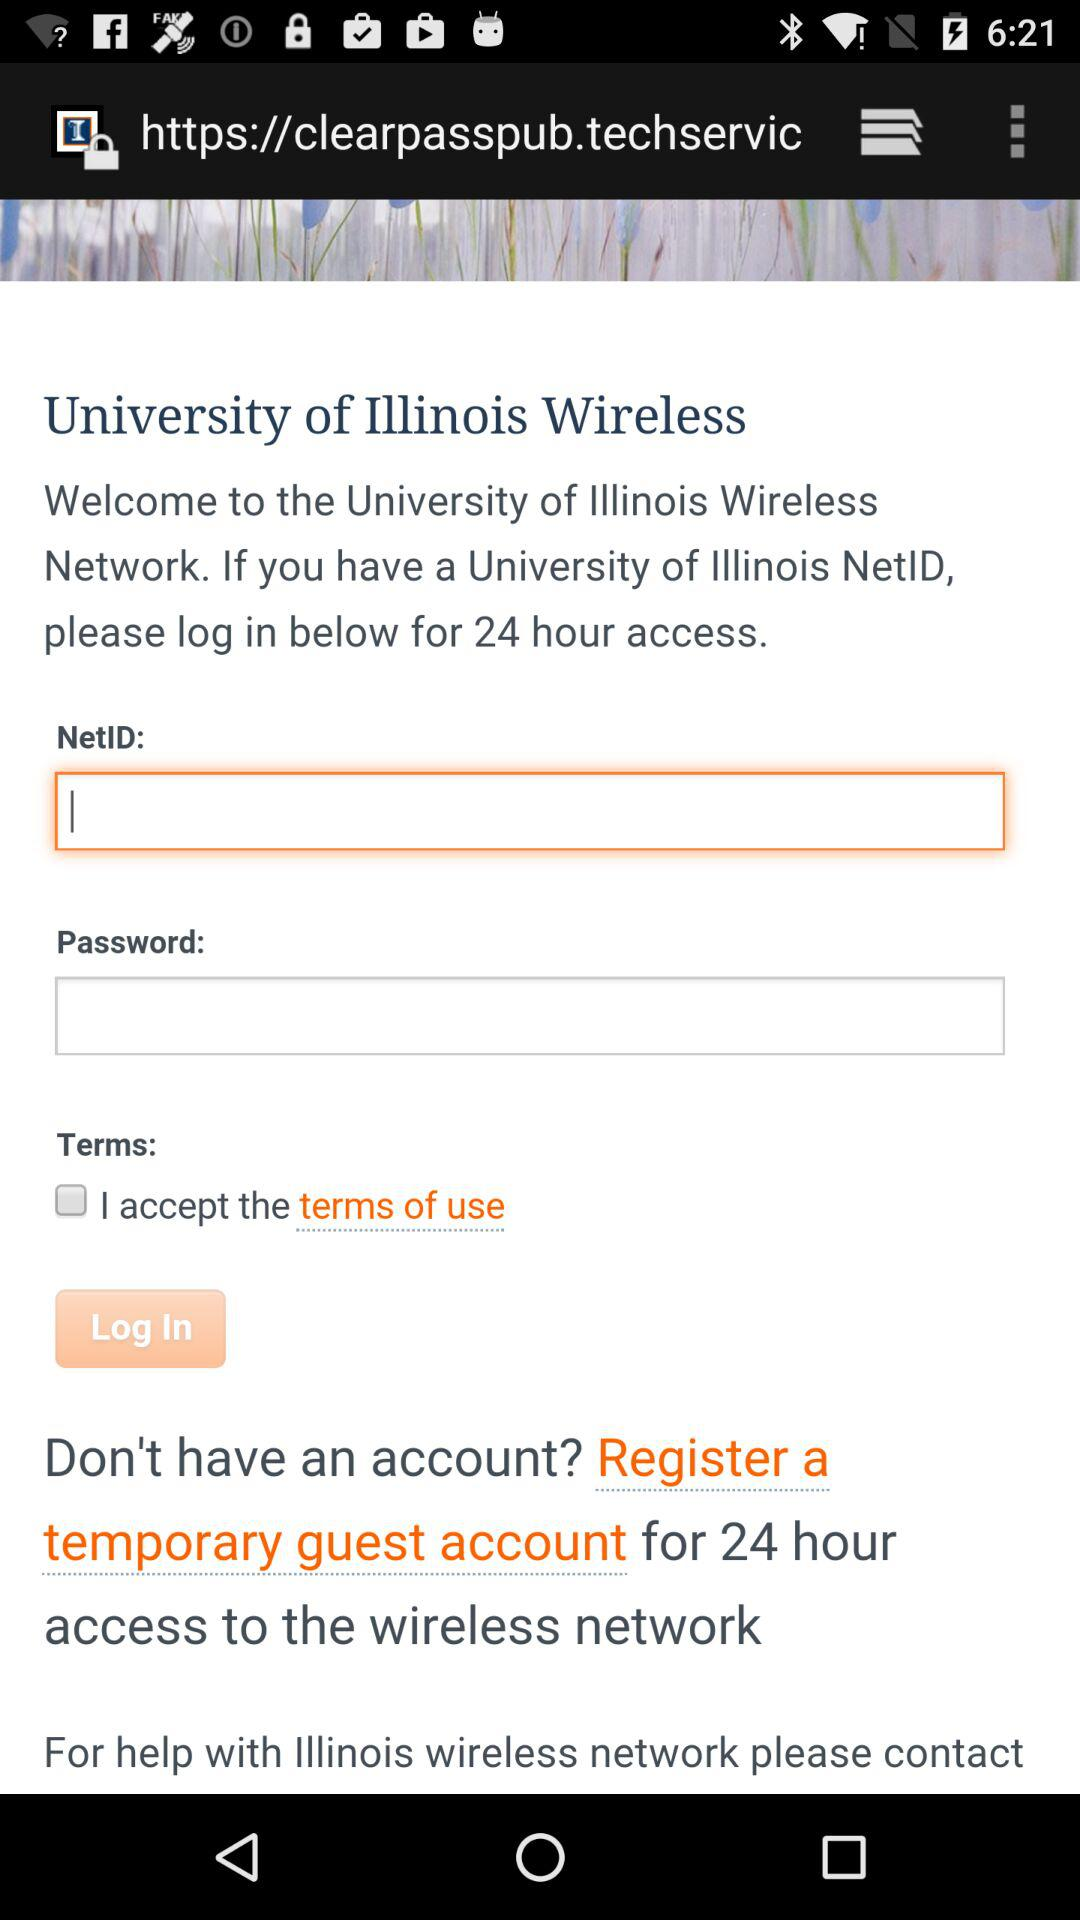What is the status of "I accept the term of use"? The status is "off". 